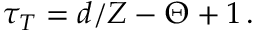Convert formula to latex. <formula><loc_0><loc_0><loc_500><loc_500>\tau _ { T } = d / Z - \Theta + 1 \, .</formula> 